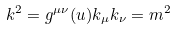Convert formula to latex. <formula><loc_0><loc_0><loc_500><loc_500>k ^ { 2 } = g ^ { \mu \nu } ( u ) k _ { \mu } k _ { \nu } = m ^ { 2 }</formula> 